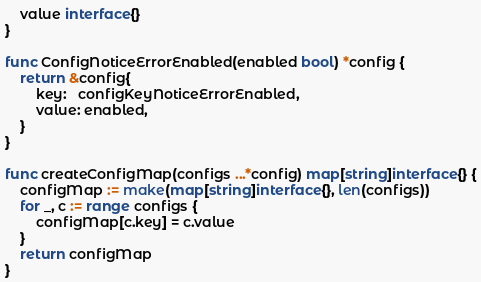<code> <loc_0><loc_0><loc_500><loc_500><_Go_>	value interface{}
}

func ConfigNoticeErrorEnabled(enabled bool) *config {
	return &config{
		key:   configKeyNoticeErrorEnabled,
		value: enabled,
	}
}

func createConfigMap(configs ...*config) map[string]interface{} {
	configMap := make(map[string]interface{}, len(configs))
	for _, c := range configs {
		configMap[c.key] = c.value
	}
	return configMap
}
</code> 